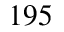<formula> <loc_0><loc_0><loc_500><loc_500>1 9 5</formula> 